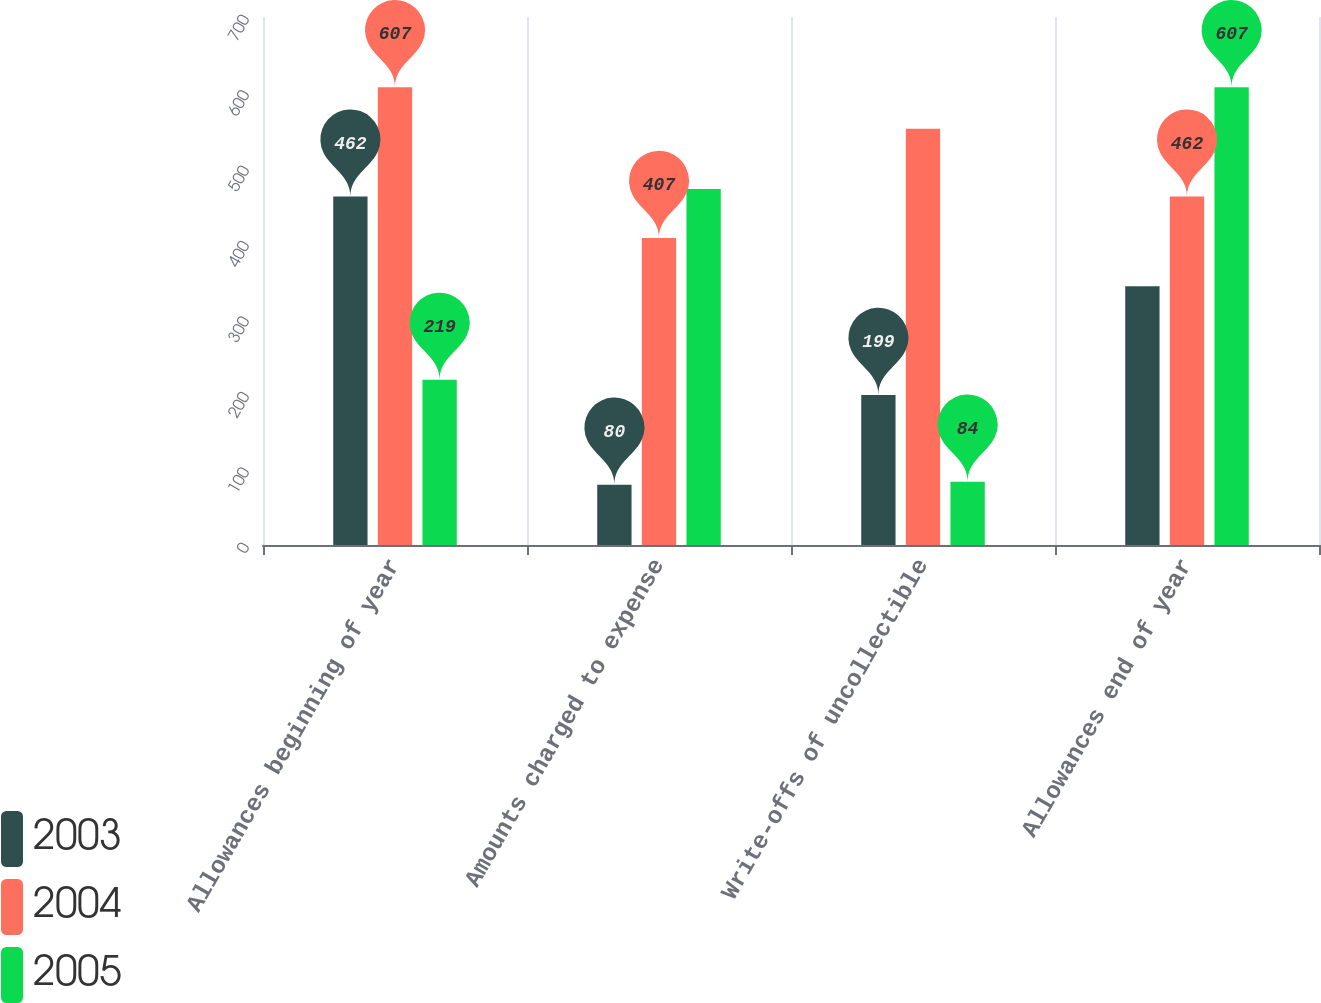<chart> <loc_0><loc_0><loc_500><loc_500><stacked_bar_chart><ecel><fcel>Allowances beginning of year<fcel>Amounts charged to expense<fcel>Write-offs of uncollectible<fcel>Allowances end of year<nl><fcel>2003<fcel>462<fcel>80<fcel>199<fcel>343<nl><fcel>2004<fcel>607<fcel>407<fcel>552<fcel>462<nl><fcel>2005<fcel>219<fcel>472<fcel>84<fcel>607<nl></chart> 